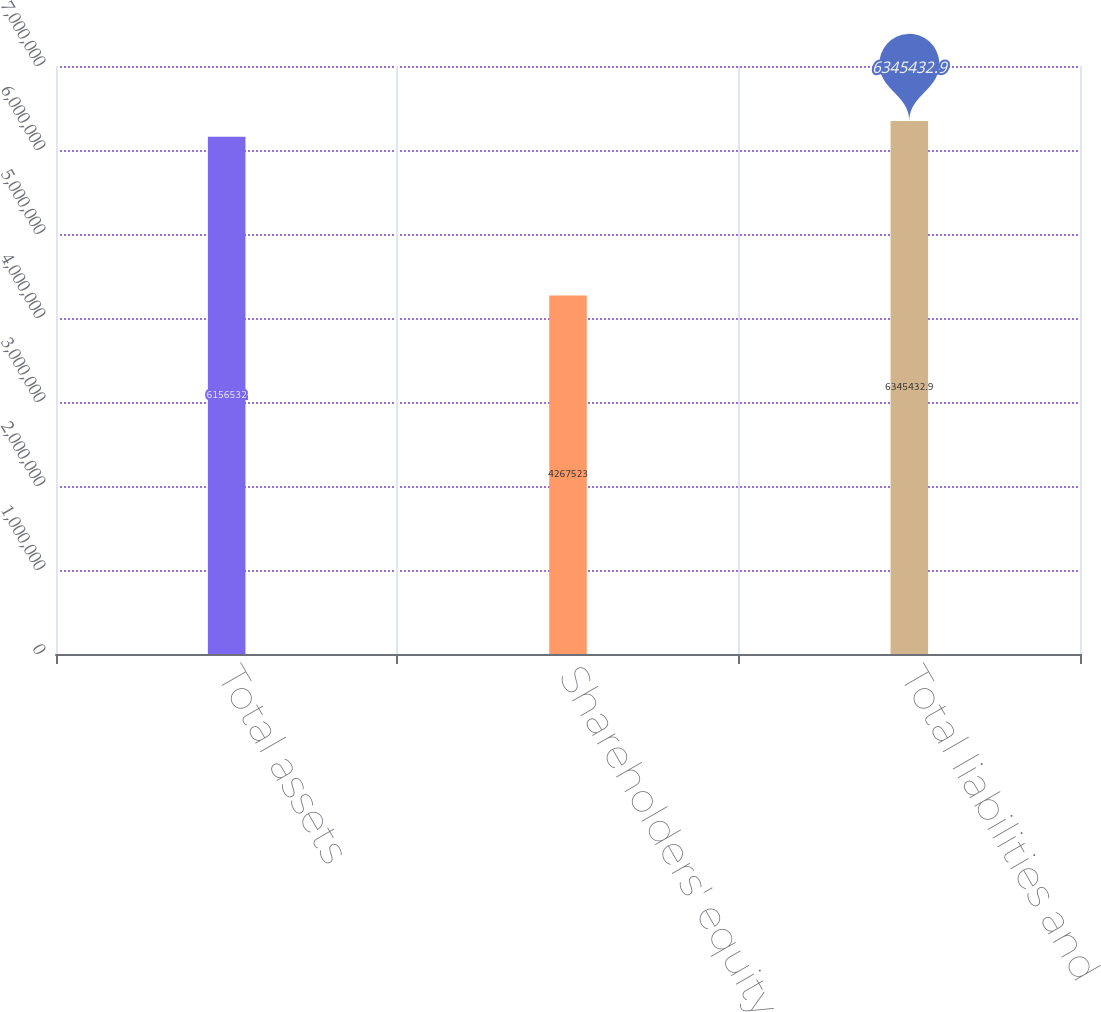Convert chart to OTSL. <chart><loc_0><loc_0><loc_500><loc_500><bar_chart><fcel>Total assets<fcel>Shareholders' equity<fcel>Total liabilities and<nl><fcel>6.15653e+06<fcel>4.26752e+06<fcel>6.34543e+06<nl></chart> 